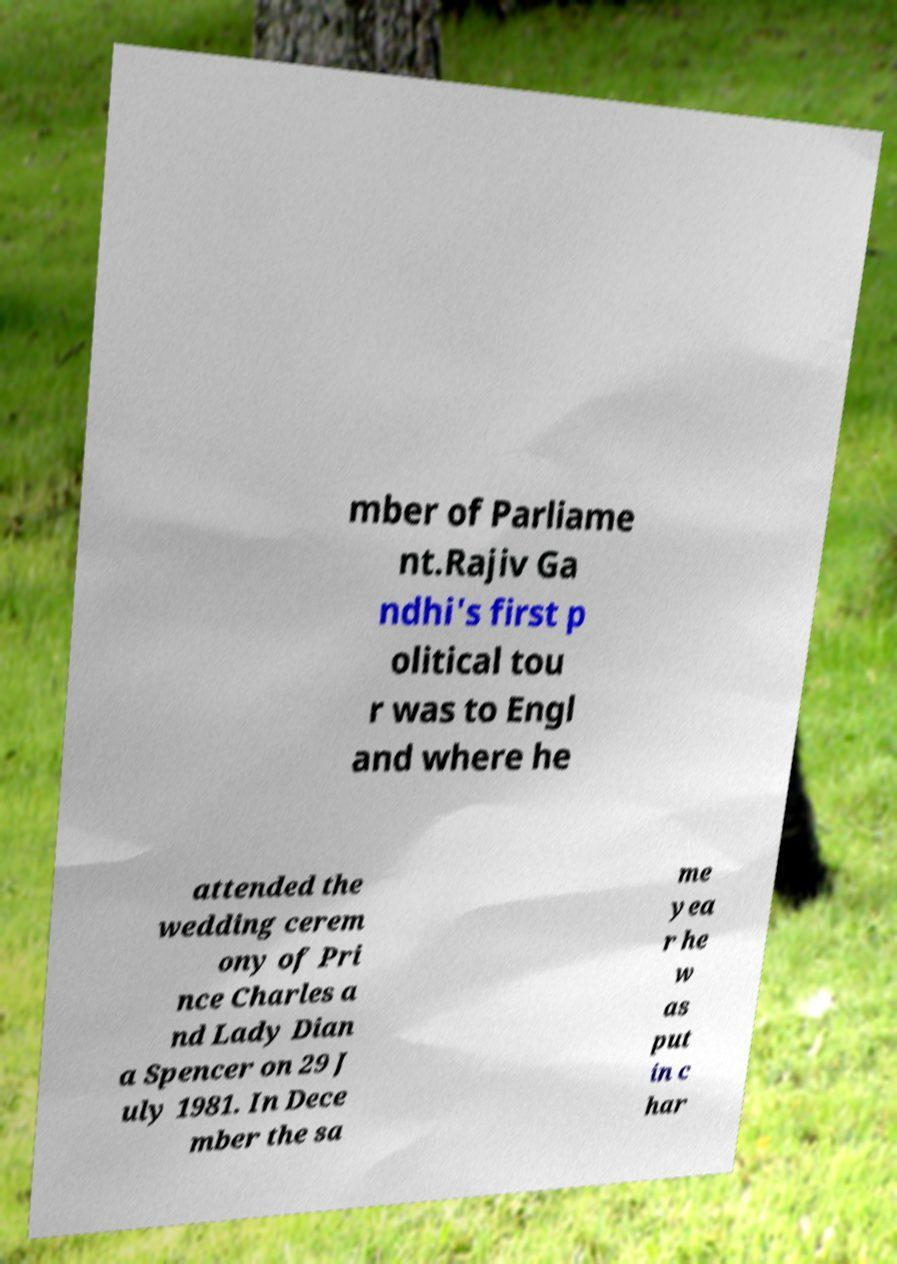For documentation purposes, I need the text within this image transcribed. Could you provide that? mber of Parliame nt.Rajiv Ga ndhi's first p olitical tou r was to Engl and where he attended the wedding cerem ony of Pri nce Charles a nd Lady Dian a Spencer on 29 J uly 1981. In Dece mber the sa me yea r he w as put in c har 